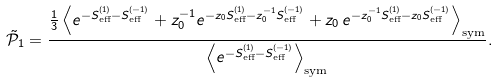<formula> <loc_0><loc_0><loc_500><loc_500>\tilde { \mathcal { P } } _ { 1 } = \frac { \frac { 1 } { 3 } \left \langle e ^ { - S _ { \text {eff} } ^ { ( 1 ) } - S _ { \text {eff} } ^ { ( - 1 ) } } + z _ { 0 } ^ { - 1 } e ^ { - z _ { 0 } S _ { \text {eff} } ^ { ( 1 ) } - z _ { 0 } ^ { - 1 } S _ { \text {eff} } ^ { ( - 1 ) } } + z _ { 0 } \, e ^ { - z _ { 0 } ^ { - 1 } S _ { \text {eff} } ^ { ( 1 ) } - z _ { 0 } S _ { \text {eff} } ^ { ( - 1 ) } } \right \rangle _ { \text {sym} } } { \left \langle e ^ { - S _ { \text {eff} } ^ { ( 1 ) } - S _ { \text {eff} } ^ { ( - 1 ) } } \right \rangle _ { \text {sym} } } .</formula> 